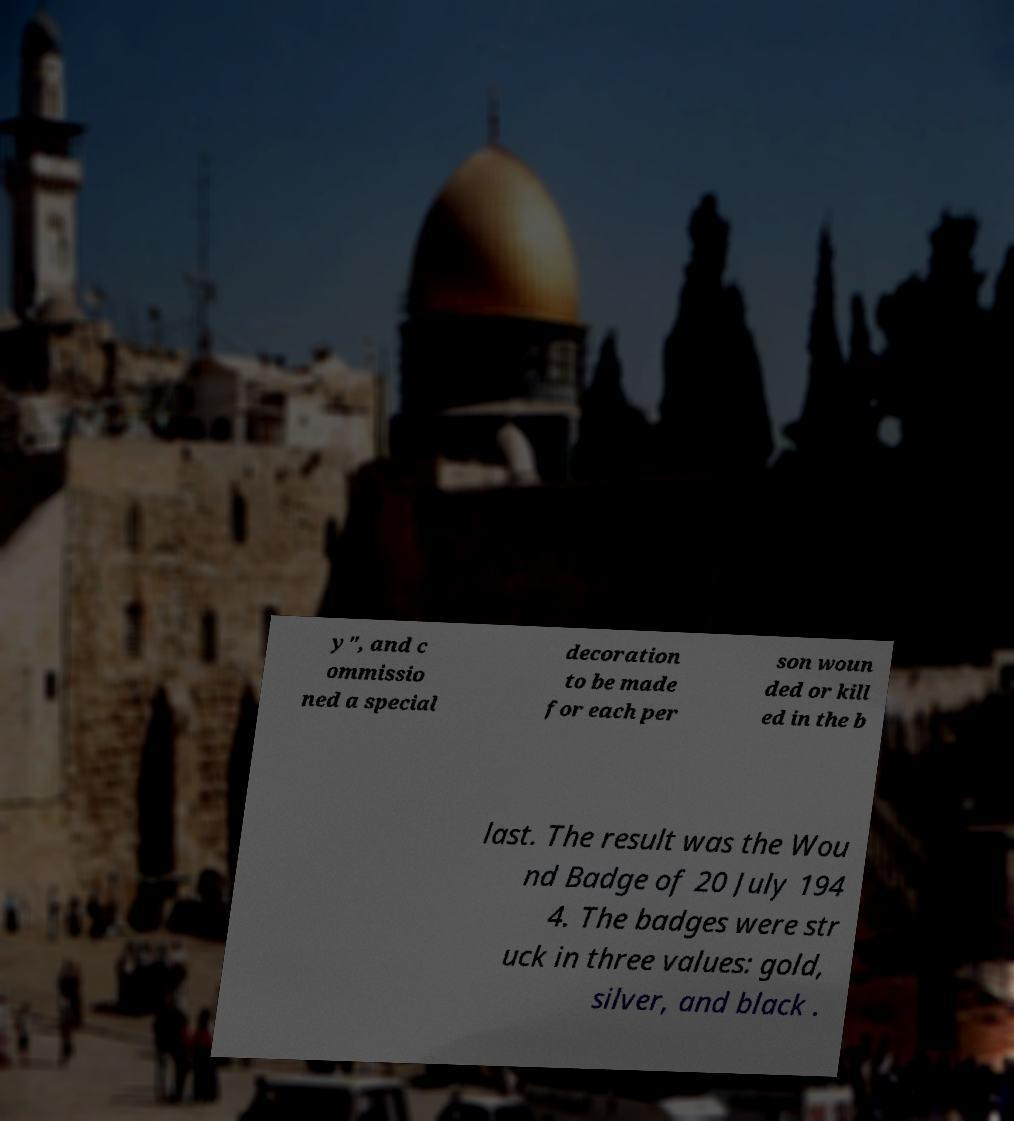Could you extract and type out the text from this image? y", and c ommissio ned a special decoration to be made for each per son woun ded or kill ed in the b last. The result was the Wou nd Badge of 20 July 194 4. The badges were str uck in three values: gold, silver, and black . 